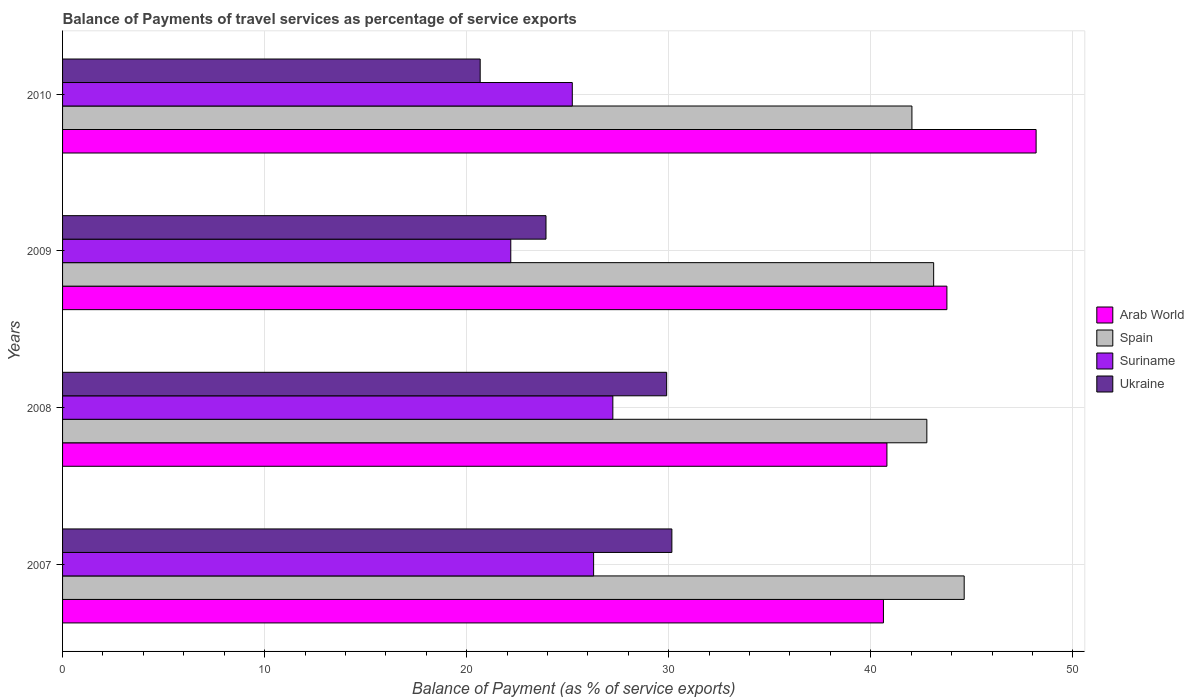How many groups of bars are there?
Your answer should be compact. 4. Are the number of bars per tick equal to the number of legend labels?
Offer a very short reply. Yes. Are the number of bars on each tick of the Y-axis equal?
Provide a short and direct response. Yes. How many bars are there on the 1st tick from the top?
Your answer should be compact. 4. What is the label of the 4th group of bars from the top?
Offer a terse response. 2007. In how many cases, is the number of bars for a given year not equal to the number of legend labels?
Make the answer very short. 0. What is the balance of payments of travel services in Suriname in 2010?
Make the answer very short. 25.23. Across all years, what is the maximum balance of payments of travel services in Ukraine?
Keep it short and to the point. 30.16. Across all years, what is the minimum balance of payments of travel services in Arab World?
Offer a terse response. 40.63. In which year was the balance of payments of travel services in Arab World maximum?
Keep it short and to the point. 2010. What is the total balance of payments of travel services in Ukraine in the graph?
Give a very brief answer. 104.65. What is the difference between the balance of payments of travel services in Spain in 2009 and that in 2010?
Your answer should be very brief. 1.08. What is the difference between the balance of payments of travel services in Ukraine in 2010 and the balance of payments of travel services in Spain in 2007?
Offer a terse response. -23.95. What is the average balance of payments of travel services in Spain per year?
Provide a short and direct response. 43.14. In the year 2008, what is the difference between the balance of payments of travel services in Arab World and balance of payments of travel services in Spain?
Your answer should be compact. -1.98. What is the ratio of the balance of payments of travel services in Arab World in 2007 to that in 2010?
Your answer should be very brief. 0.84. Is the balance of payments of travel services in Arab World in 2007 less than that in 2008?
Make the answer very short. Yes. What is the difference between the highest and the second highest balance of payments of travel services in Suriname?
Ensure brevity in your answer.  0.95. What is the difference between the highest and the lowest balance of payments of travel services in Spain?
Offer a very short reply. 2.59. In how many years, is the balance of payments of travel services in Spain greater than the average balance of payments of travel services in Spain taken over all years?
Provide a succinct answer. 1. What does the 2nd bar from the top in 2007 represents?
Give a very brief answer. Suriname. What does the 4th bar from the bottom in 2008 represents?
Your response must be concise. Ukraine. How many bars are there?
Provide a succinct answer. 16. How many years are there in the graph?
Provide a short and direct response. 4. Does the graph contain any zero values?
Offer a very short reply. No. Does the graph contain grids?
Your response must be concise. Yes. Where does the legend appear in the graph?
Keep it short and to the point. Center right. How many legend labels are there?
Make the answer very short. 4. What is the title of the graph?
Offer a very short reply. Balance of Payments of travel services as percentage of service exports. What is the label or title of the X-axis?
Ensure brevity in your answer.  Balance of Payment (as % of service exports). What is the label or title of the Y-axis?
Provide a succinct answer. Years. What is the Balance of Payment (as % of service exports) of Arab World in 2007?
Your answer should be compact. 40.63. What is the Balance of Payment (as % of service exports) of Spain in 2007?
Your answer should be compact. 44.62. What is the Balance of Payment (as % of service exports) of Suriname in 2007?
Make the answer very short. 26.28. What is the Balance of Payment (as % of service exports) of Ukraine in 2007?
Ensure brevity in your answer.  30.16. What is the Balance of Payment (as % of service exports) in Arab World in 2008?
Keep it short and to the point. 40.8. What is the Balance of Payment (as % of service exports) in Spain in 2008?
Keep it short and to the point. 42.78. What is the Balance of Payment (as % of service exports) of Suriname in 2008?
Your answer should be very brief. 27.23. What is the Balance of Payment (as % of service exports) of Ukraine in 2008?
Offer a very short reply. 29.9. What is the Balance of Payment (as % of service exports) of Arab World in 2009?
Your answer should be very brief. 43.77. What is the Balance of Payment (as % of service exports) of Spain in 2009?
Offer a very short reply. 43.11. What is the Balance of Payment (as % of service exports) in Suriname in 2009?
Provide a short and direct response. 22.18. What is the Balance of Payment (as % of service exports) of Ukraine in 2009?
Keep it short and to the point. 23.93. What is the Balance of Payment (as % of service exports) of Arab World in 2010?
Keep it short and to the point. 48.18. What is the Balance of Payment (as % of service exports) of Spain in 2010?
Ensure brevity in your answer.  42.04. What is the Balance of Payment (as % of service exports) of Suriname in 2010?
Your answer should be compact. 25.23. What is the Balance of Payment (as % of service exports) in Ukraine in 2010?
Offer a terse response. 20.67. Across all years, what is the maximum Balance of Payment (as % of service exports) in Arab World?
Keep it short and to the point. 48.18. Across all years, what is the maximum Balance of Payment (as % of service exports) in Spain?
Your response must be concise. 44.62. Across all years, what is the maximum Balance of Payment (as % of service exports) in Suriname?
Provide a short and direct response. 27.23. Across all years, what is the maximum Balance of Payment (as % of service exports) of Ukraine?
Keep it short and to the point. 30.16. Across all years, what is the minimum Balance of Payment (as % of service exports) in Arab World?
Ensure brevity in your answer.  40.63. Across all years, what is the minimum Balance of Payment (as % of service exports) in Spain?
Offer a terse response. 42.04. Across all years, what is the minimum Balance of Payment (as % of service exports) of Suriname?
Your answer should be very brief. 22.18. Across all years, what is the minimum Balance of Payment (as % of service exports) of Ukraine?
Give a very brief answer. 20.67. What is the total Balance of Payment (as % of service exports) in Arab World in the graph?
Offer a terse response. 173.38. What is the total Balance of Payment (as % of service exports) of Spain in the graph?
Make the answer very short. 172.55. What is the total Balance of Payment (as % of service exports) in Suriname in the graph?
Offer a terse response. 100.93. What is the total Balance of Payment (as % of service exports) in Ukraine in the graph?
Your response must be concise. 104.65. What is the difference between the Balance of Payment (as % of service exports) in Arab World in 2007 and that in 2008?
Ensure brevity in your answer.  -0.17. What is the difference between the Balance of Payment (as % of service exports) in Spain in 2007 and that in 2008?
Offer a terse response. 1.85. What is the difference between the Balance of Payment (as % of service exports) in Suriname in 2007 and that in 2008?
Your response must be concise. -0.95. What is the difference between the Balance of Payment (as % of service exports) of Ukraine in 2007 and that in 2008?
Offer a terse response. 0.26. What is the difference between the Balance of Payment (as % of service exports) in Arab World in 2007 and that in 2009?
Offer a terse response. -3.14. What is the difference between the Balance of Payment (as % of service exports) in Spain in 2007 and that in 2009?
Make the answer very short. 1.51. What is the difference between the Balance of Payment (as % of service exports) in Suriname in 2007 and that in 2009?
Your response must be concise. 4.1. What is the difference between the Balance of Payment (as % of service exports) in Ukraine in 2007 and that in 2009?
Your response must be concise. 6.23. What is the difference between the Balance of Payment (as % of service exports) of Arab World in 2007 and that in 2010?
Offer a very short reply. -7.56. What is the difference between the Balance of Payment (as % of service exports) of Spain in 2007 and that in 2010?
Provide a succinct answer. 2.59. What is the difference between the Balance of Payment (as % of service exports) in Suriname in 2007 and that in 2010?
Your answer should be very brief. 1.05. What is the difference between the Balance of Payment (as % of service exports) of Ukraine in 2007 and that in 2010?
Offer a very short reply. 9.49. What is the difference between the Balance of Payment (as % of service exports) in Arab World in 2008 and that in 2009?
Offer a terse response. -2.97. What is the difference between the Balance of Payment (as % of service exports) in Spain in 2008 and that in 2009?
Give a very brief answer. -0.34. What is the difference between the Balance of Payment (as % of service exports) of Suriname in 2008 and that in 2009?
Make the answer very short. 5.05. What is the difference between the Balance of Payment (as % of service exports) of Ukraine in 2008 and that in 2009?
Provide a succinct answer. 5.97. What is the difference between the Balance of Payment (as % of service exports) in Arab World in 2008 and that in 2010?
Offer a terse response. -7.38. What is the difference between the Balance of Payment (as % of service exports) in Spain in 2008 and that in 2010?
Your answer should be compact. 0.74. What is the difference between the Balance of Payment (as % of service exports) in Suriname in 2008 and that in 2010?
Give a very brief answer. 2.01. What is the difference between the Balance of Payment (as % of service exports) of Ukraine in 2008 and that in 2010?
Your response must be concise. 9.23. What is the difference between the Balance of Payment (as % of service exports) of Arab World in 2009 and that in 2010?
Your answer should be compact. -4.42. What is the difference between the Balance of Payment (as % of service exports) in Spain in 2009 and that in 2010?
Your response must be concise. 1.08. What is the difference between the Balance of Payment (as % of service exports) in Suriname in 2009 and that in 2010?
Provide a short and direct response. -3.04. What is the difference between the Balance of Payment (as % of service exports) in Ukraine in 2009 and that in 2010?
Ensure brevity in your answer.  3.26. What is the difference between the Balance of Payment (as % of service exports) of Arab World in 2007 and the Balance of Payment (as % of service exports) of Spain in 2008?
Make the answer very short. -2.15. What is the difference between the Balance of Payment (as % of service exports) of Arab World in 2007 and the Balance of Payment (as % of service exports) of Suriname in 2008?
Your answer should be compact. 13.39. What is the difference between the Balance of Payment (as % of service exports) of Arab World in 2007 and the Balance of Payment (as % of service exports) of Ukraine in 2008?
Keep it short and to the point. 10.73. What is the difference between the Balance of Payment (as % of service exports) of Spain in 2007 and the Balance of Payment (as % of service exports) of Suriname in 2008?
Your answer should be very brief. 17.39. What is the difference between the Balance of Payment (as % of service exports) in Spain in 2007 and the Balance of Payment (as % of service exports) in Ukraine in 2008?
Provide a succinct answer. 14.72. What is the difference between the Balance of Payment (as % of service exports) in Suriname in 2007 and the Balance of Payment (as % of service exports) in Ukraine in 2008?
Your answer should be very brief. -3.62. What is the difference between the Balance of Payment (as % of service exports) of Arab World in 2007 and the Balance of Payment (as % of service exports) of Spain in 2009?
Give a very brief answer. -2.49. What is the difference between the Balance of Payment (as % of service exports) in Arab World in 2007 and the Balance of Payment (as % of service exports) in Suriname in 2009?
Provide a short and direct response. 18.44. What is the difference between the Balance of Payment (as % of service exports) in Arab World in 2007 and the Balance of Payment (as % of service exports) in Ukraine in 2009?
Provide a short and direct response. 16.7. What is the difference between the Balance of Payment (as % of service exports) in Spain in 2007 and the Balance of Payment (as % of service exports) in Suriname in 2009?
Provide a succinct answer. 22.44. What is the difference between the Balance of Payment (as % of service exports) in Spain in 2007 and the Balance of Payment (as % of service exports) in Ukraine in 2009?
Provide a short and direct response. 20.7. What is the difference between the Balance of Payment (as % of service exports) of Suriname in 2007 and the Balance of Payment (as % of service exports) of Ukraine in 2009?
Offer a terse response. 2.36. What is the difference between the Balance of Payment (as % of service exports) of Arab World in 2007 and the Balance of Payment (as % of service exports) of Spain in 2010?
Offer a very short reply. -1.41. What is the difference between the Balance of Payment (as % of service exports) of Arab World in 2007 and the Balance of Payment (as % of service exports) of Suriname in 2010?
Make the answer very short. 15.4. What is the difference between the Balance of Payment (as % of service exports) of Arab World in 2007 and the Balance of Payment (as % of service exports) of Ukraine in 2010?
Keep it short and to the point. 19.96. What is the difference between the Balance of Payment (as % of service exports) in Spain in 2007 and the Balance of Payment (as % of service exports) in Suriname in 2010?
Your answer should be very brief. 19.4. What is the difference between the Balance of Payment (as % of service exports) in Spain in 2007 and the Balance of Payment (as % of service exports) in Ukraine in 2010?
Your response must be concise. 23.95. What is the difference between the Balance of Payment (as % of service exports) in Suriname in 2007 and the Balance of Payment (as % of service exports) in Ukraine in 2010?
Offer a very short reply. 5.61. What is the difference between the Balance of Payment (as % of service exports) of Arab World in 2008 and the Balance of Payment (as % of service exports) of Spain in 2009?
Make the answer very short. -2.31. What is the difference between the Balance of Payment (as % of service exports) in Arab World in 2008 and the Balance of Payment (as % of service exports) in Suriname in 2009?
Provide a succinct answer. 18.62. What is the difference between the Balance of Payment (as % of service exports) of Arab World in 2008 and the Balance of Payment (as % of service exports) of Ukraine in 2009?
Your answer should be very brief. 16.87. What is the difference between the Balance of Payment (as % of service exports) in Spain in 2008 and the Balance of Payment (as % of service exports) in Suriname in 2009?
Provide a succinct answer. 20.59. What is the difference between the Balance of Payment (as % of service exports) of Spain in 2008 and the Balance of Payment (as % of service exports) of Ukraine in 2009?
Provide a short and direct response. 18.85. What is the difference between the Balance of Payment (as % of service exports) of Suriname in 2008 and the Balance of Payment (as % of service exports) of Ukraine in 2009?
Keep it short and to the point. 3.31. What is the difference between the Balance of Payment (as % of service exports) of Arab World in 2008 and the Balance of Payment (as % of service exports) of Spain in 2010?
Ensure brevity in your answer.  -1.24. What is the difference between the Balance of Payment (as % of service exports) of Arab World in 2008 and the Balance of Payment (as % of service exports) of Suriname in 2010?
Your response must be concise. 15.57. What is the difference between the Balance of Payment (as % of service exports) of Arab World in 2008 and the Balance of Payment (as % of service exports) of Ukraine in 2010?
Make the answer very short. 20.13. What is the difference between the Balance of Payment (as % of service exports) in Spain in 2008 and the Balance of Payment (as % of service exports) in Suriname in 2010?
Ensure brevity in your answer.  17.55. What is the difference between the Balance of Payment (as % of service exports) in Spain in 2008 and the Balance of Payment (as % of service exports) in Ukraine in 2010?
Provide a short and direct response. 22.11. What is the difference between the Balance of Payment (as % of service exports) in Suriname in 2008 and the Balance of Payment (as % of service exports) in Ukraine in 2010?
Ensure brevity in your answer.  6.57. What is the difference between the Balance of Payment (as % of service exports) in Arab World in 2009 and the Balance of Payment (as % of service exports) in Spain in 2010?
Keep it short and to the point. 1.73. What is the difference between the Balance of Payment (as % of service exports) in Arab World in 2009 and the Balance of Payment (as % of service exports) in Suriname in 2010?
Make the answer very short. 18.54. What is the difference between the Balance of Payment (as % of service exports) of Arab World in 2009 and the Balance of Payment (as % of service exports) of Ukraine in 2010?
Make the answer very short. 23.1. What is the difference between the Balance of Payment (as % of service exports) in Spain in 2009 and the Balance of Payment (as % of service exports) in Suriname in 2010?
Offer a very short reply. 17.88. What is the difference between the Balance of Payment (as % of service exports) in Spain in 2009 and the Balance of Payment (as % of service exports) in Ukraine in 2010?
Ensure brevity in your answer.  22.44. What is the difference between the Balance of Payment (as % of service exports) in Suriname in 2009 and the Balance of Payment (as % of service exports) in Ukraine in 2010?
Provide a short and direct response. 1.51. What is the average Balance of Payment (as % of service exports) of Arab World per year?
Make the answer very short. 43.34. What is the average Balance of Payment (as % of service exports) in Spain per year?
Ensure brevity in your answer.  43.14. What is the average Balance of Payment (as % of service exports) of Suriname per year?
Provide a succinct answer. 25.23. What is the average Balance of Payment (as % of service exports) of Ukraine per year?
Provide a short and direct response. 26.16. In the year 2007, what is the difference between the Balance of Payment (as % of service exports) of Arab World and Balance of Payment (as % of service exports) of Spain?
Give a very brief answer. -4. In the year 2007, what is the difference between the Balance of Payment (as % of service exports) in Arab World and Balance of Payment (as % of service exports) in Suriname?
Keep it short and to the point. 14.34. In the year 2007, what is the difference between the Balance of Payment (as % of service exports) of Arab World and Balance of Payment (as % of service exports) of Ukraine?
Give a very brief answer. 10.47. In the year 2007, what is the difference between the Balance of Payment (as % of service exports) in Spain and Balance of Payment (as % of service exports) in Suriname?
Ensure brevity in your answer.  18.34. In the year 2007, what is the difference between the Balance of Payment (as % of service exports) in Spain and Balance of Payment (as % of service exports) in Ukraine?
Your answer should be very brief. 14.47. In the year 2007, what is the difference between the Balance of Payment (as % of service exports) in Suriname and Balance of Payment (as % of service exports) in Ukraine?
Give a very brief answer. -3.87. In the year 2008, what is the difference between the Balance of Payment (as % of service exports) of Arab World and Balance of Payment (as % of service exports) of Spain?
Your answer should be compact. -1.98. In the year 2008, what is the difference between the Balance of Payment (as % of service exports) in Arab World and Balance of Payment (as % of service exports) in Suriname?
Offer a terse response. 13.57. In the year 2008, what is the difference between the Balance of Payment (as % of service exports) in Arab World and Balance of Payment (as % of service exports) in Ukraine?
Give a very brief answer. 10.9. In the year 2008, what is the difference between the Balance of Payment (as % of service exports) of Spain and Balance of Payment (as % of service exports) of Suriname?
Your answer should be compact. 15.54. In the year 2008, what is the difference between the Balance of Payment (as % of service exports) in Spain and Balance of Payment (as % of service exports) in Ukraine?
Your answer should be compact. 12.88. In the year 2008, what is the difference between the Balance of Payment (as % of service exports) in Suriname and Balance of Payment (as % of service exports) in Ukraine?
Your answer should be very brief. -2.66. In the year 2009, what is the difference between the Balance of Payment (as % of service exports) in Arab World and Balance of Payment (as % of service exports) in Spain?
Offer a terse response. 0.66. In the year 2009, what is the difference between the Balance of Payment (as % of service exports) in Arab World and Balance of Payment (as % of service exports) in Suriname?
Ensure brevity in your answer.  21.58. In the year 2009, what is the difference between the Balance of Payment (as % of service exports) in Arab World and Balance of Payment (as % of service exports) in Ukraine?
Your answer should be very brief. 19.84. In the year 2009, what is the difference between the Balance of Payment (as % of service exports) of Spain and Balance of Payment (as % of service exports) of Suriname?
Provide a short and direct response. 20.93. In the year 2009, what is the difference between the Balance of Payment (as % of service exports) in Spain and Balance of Payment (as % of service exports) in Ukraine?
Provide a short and direct response. 19.19. In the year 2009, what is the difference between the Balance of Payment (as % of service exports) of Suriname and Balance of Payment (as % of service exports) of Ukraine?
Offer a very short reply. -1.74. In the year 2010, what is the difference between the Balance of Payment (as % of service exports) of Arab World and Balance of Payment (as % of service exports) of Spain?
Offer a terse response. 6.15. In the year 2010, what is the difference between the Balance of Payment (as % of service exports) in Arab World and Balance of Payment (as % of service exports) in Suriname?
Keep it short and to the point. 22.96. In the year 2010, what is the difference between the Balance of Payment (as % of service exports) in Arab World and Balance of Payment (as % of service exports) in Ukraine?
Your response must be concise. 27.51. In the year 2010, what is the difference between the Balance of Payment (as % of service exports) of Spain and Balance of Payment (as % of service exports) of Suriname?
Ensure brevity in your answer.  16.81. In the year 2010, what is the difference between the Balance of Payment (as % of service exports) in Spain and Balance of Payment (as % of service exports) in Ukraine?
Keep it short and to the point. 21.37. In the year 2010, what is the difference between the Balance of Payment (as % of service exports) in Suriname and Balance of Payment (as % of service exports) in Ukraine?
Provide a short and direct response. 4.56. What is the ratio of the Balance of Payment (as % of service exports) of Spain in 2007 to that in 2008?
Give a very brief answer. 1.04. What is the ratio of the Balance of Payment (as % of service exports) of Suriname in 2007 to that in 2008?
Keep it short and to the point. 0.97. What is the ratio of the Balance of Payment (as % of service exports) in Ukraine in 2007 to that in 2008?
Provide a short and direct response. 1.01. What is the ratio of the Balance of Payment (as % of service exports) of Arab World in 2007 to that in 2009?
Your answer should be compact. 0.93. What is the ratio of the Balance of Payment (as % of service exports) of Spain in 2007 to that in 2009?
Your answer should be compact. 1.03. What is the ratio of the Balance of Payment (as % of service exports) in Suriname in 2007 to that in 2009?
Your answer should be very brief. 1.18. What is the ratio of the Balance of Payment (as % of service exports) in Ukraine in 2007 to that in 2009?
Provide a succinct answer. 1.26. What is the ratio of the Balance of Payment (as % of service exports) of Arab World in 2007 to that in 2010?
Ensure brevity in your answer.  0.84. What is the ratio of the Balance of Payment (as % of service exports) in Spain in 2007 to that in 2010?
Your response must be concise. 1.06. What is the ratio of the Balance of Payment (as % of service exports) of Suriname in 2007 to that in 2010?
Give a very brief answer. 1.04. What is the ratio of the Balance of Payment (as % of service exports) in Ukraine in 2007 to that in 2010?
Provide a succinct answer. 1.46. What is the ratio of the Balance of Payment (as % of service exports) of Arab World in 2008 to that in 2009?
Offer a very short reply. 0.93. What is the ratio of the Balance of Payment (as % of service exports) in Spain in 2008 to that in 2009?
Offer a terse response. 0.99. What is the ratio of the Balance of Payment (as % of service exports) of Suriname in 2008 to that in 2009?
Provide a short and direct response. 1.23. What is the ratio of the Balance of Payment (as % of service exports) of Ukraine in 2008 to that in 2009?
Provide a succinct answer. 1.25. What is the ratio of the Balance of Payment (as % of service exports) in Arab World in 2008 to that in 2010?
Give a very brief answer. 0.85. What is the ratio of the Balance of Payment (as % of service exports) in Spain in 2008 to that in 2010?
Provide a short and direct response. 1.02. What is the ratio of the Balance of Payment (as % of service exports) of Suriname in 2008 to that in 2010?
Your response must be concise. 1.08. What is the ratio of the Balance of Payment (as % of service exports) of Ukraine in 2008 to that in 2010?
Provide a short and direct response. 1.45. What is the ratio of the Balance of Payment (as % of service exports) of Arab World in 2009 to that in 2010?
Give a very brief answer. 0.91. What is the ratio of the Balance of Payment (as % of service exports) in Spain in 2009 to that in 2010?
Offer a very short reply. 1.03. What is the ratio of the Balance of Payment (as % of service exports) in Suriname in 2009 to that in 2010?
Your answer should be compact. 0.88. What is the ratio of the Balance of Payment (as % of service exports) of Ukraine in 2009 to that in 2010?
Offer a terse response. 1.16. What is the difference between the highest and the second highest Balance of Payment (as % of service exports) of Arab World?
Your answer should be very brief. 4.42. What is the difference between the highest and the second highest Balance of Payment (as % of service exports) of Spain?
Give a very brief answer. 1.51. What is the difference between the highest and the second highest Balance of Payment (as % of service exports) in Suriname?
Keep it short and to the point. 0.95. What is the difference between the highest and the second highest Balance of Payment (as % of service exports) of Ukraine?
Offer a very short reply. 0.26. What is the difference between the highest and the lowest Balance of Payment (as % of service exports) of Arab World?
Provide a succinct answer. 7.56. What is the difference between the highest and the lowest Balance of Payment (as % of service exports) of Spain?
Your response must be concise. 2.59. What is the difference between the highest and the lowest Balance of Payment (as % of service exports) of Suriname?
Provide a short and direct response. 5.05. What is the difference between the highest and the lowest Balance of Payment (as % of service exports) of Ukraine?
Provide a succinct answer. 9.49. 